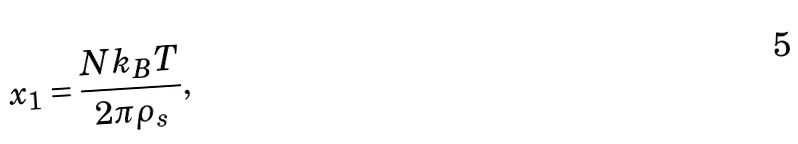<formula> <loc_0><loc_0><loc_500><loc_500>x _ { 1 } = \frac { N k _ { B } T } { 2 \pi \rho _ { s } } ,</formula> 